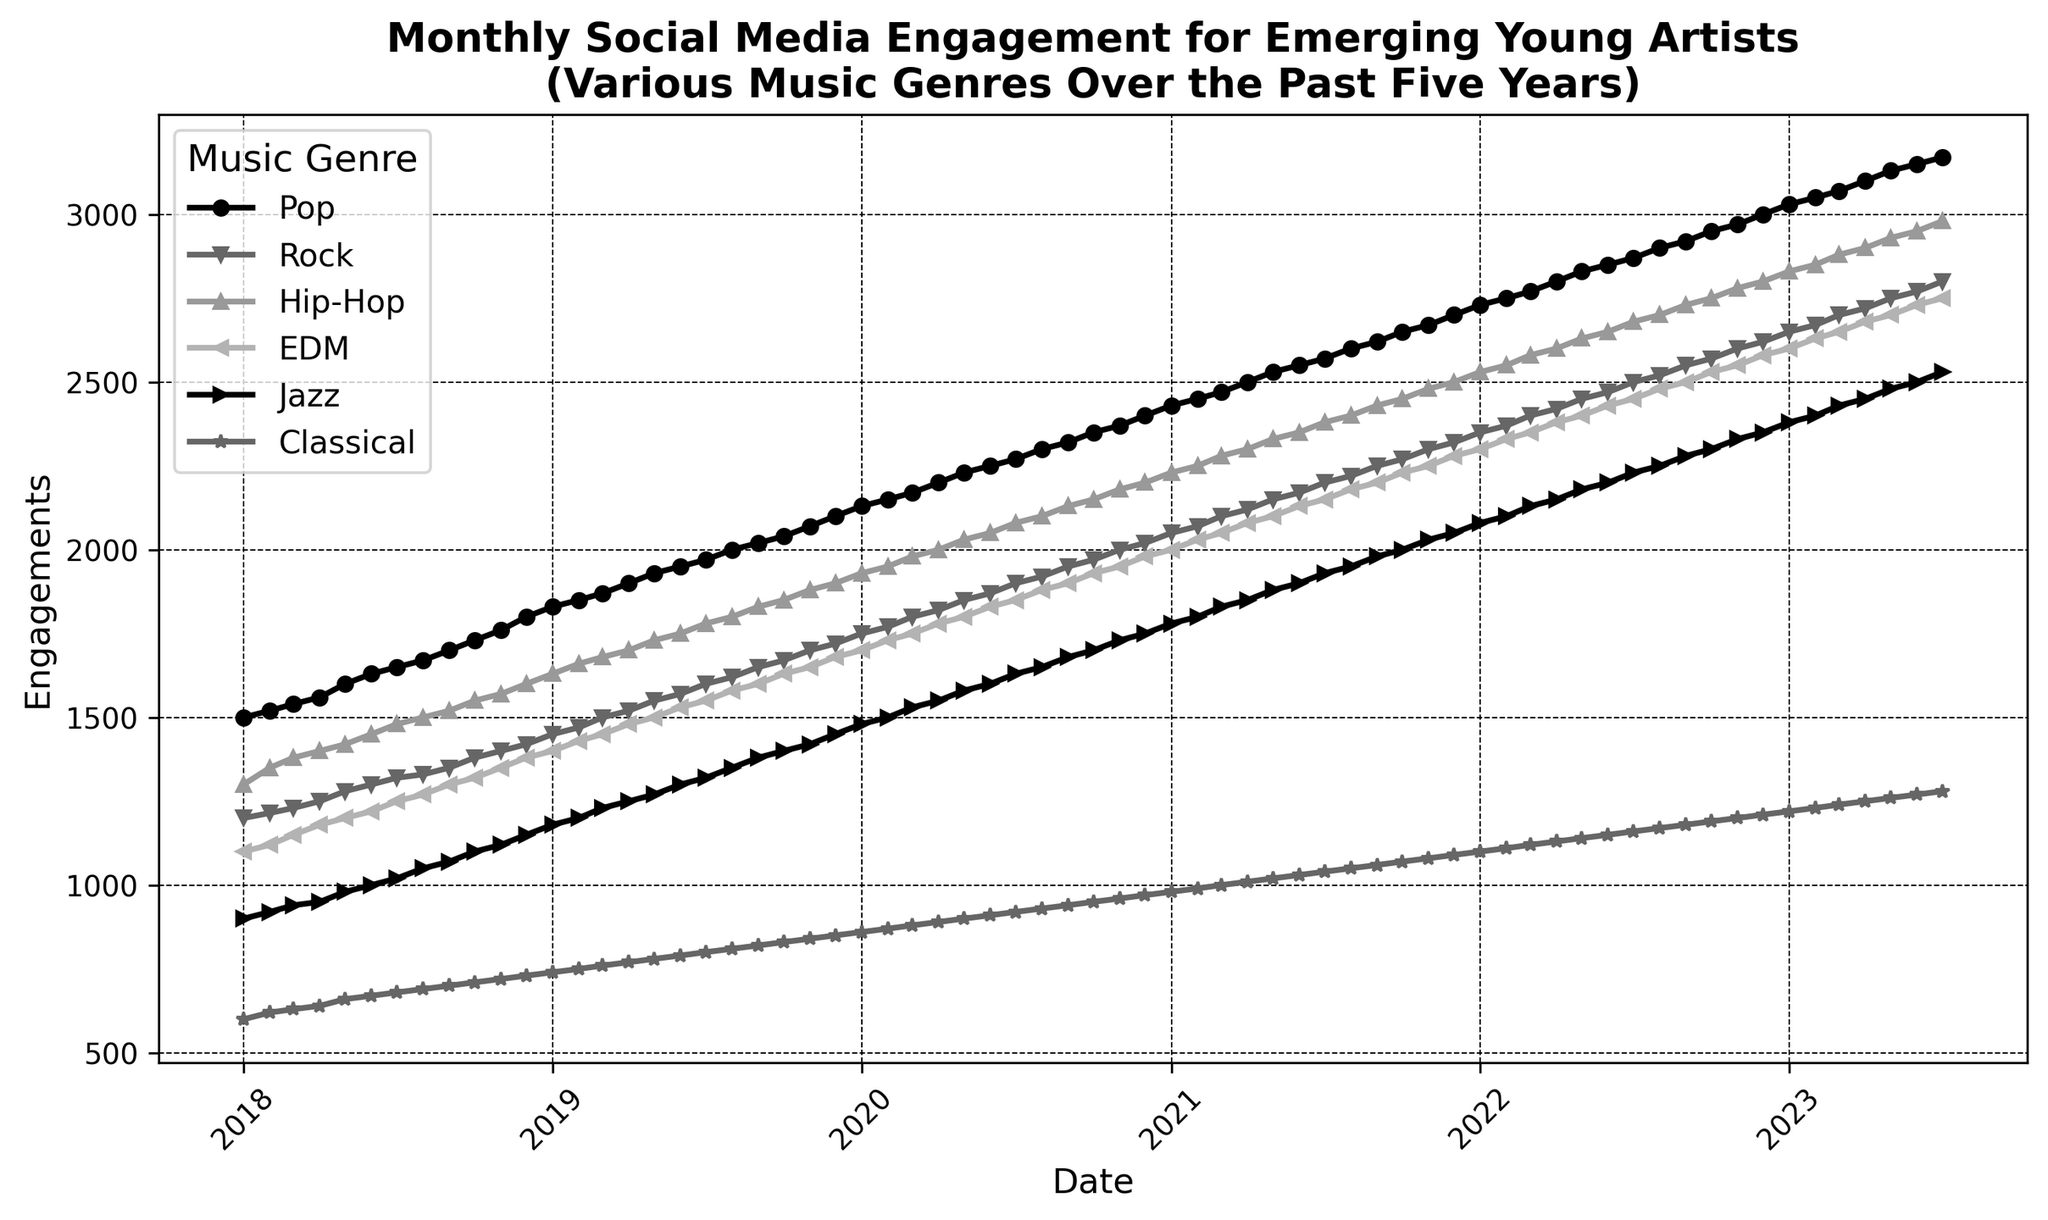Which genre shows the highest engagement in July 2023? From the plot, we look for the genre line that peaks in July 2023. The genres are indicated by different markers, and "Hip-Hop" reaches the highest point in that month.
Answer: Hip-Hop Did Rock engagement ever surpass Pop engagement from 2018 to 2023? We compare the lines representing Rock and Pop over the entire timeline. The Pop line is always above the Rock line, indicating Rock never surpassed Pop in engagement.
Answer: No Which month in 2019 did EDM see the fastest growth in engagement? By examining the EDM line, we observe the segments for sharpest increases. Between October and November 2019, there is the steepest incline in the plot for EDM.
Answer: November 2019 Between Jazz and Classical, which genre had a higher engagement by the end of 2021? We focus on the endpoint in December 2021 for both Jazz and Classical lines. Jazz ends higher than Classical according to the height of the lines.
Answer: Jazz On average, how many engagements did Classical music receive per year? To find the average per year, sum the engagements per year and then divide by the number of months. For instance, in 2018, Classical received 600+620+...+740 = 9240, average = 9240/12 = 770; repeat for all years and average this result.
Answer: 970.5 What's the total engagement growth for Hip-Hop from January 2018 to July 2023? Determine the engagement in January 2018 (1300) and in July 2023 (2980), then calculate the difference: 2980 - 1300.
Answer: 1680 Which genre consistently showed the least engagement over the entire period? By checking the relative height and position of the lines across the entire timeline, Classical consistently showed the lowest engagement.
Answer: Classical During which year did Pop's engagement increase the most? Look at the yearly increments for Pop. Calculate the difference for each year, with 2020 showing the largest increase from 2100 to 2400 (300 increment).
Answer: 2020 Compare the engagement of EDM and Jazz in March 2020. Which had higher and by how much? Locate the engagement values in March 2020 for EDM (1750) and Jazz (1530). Subtract Jazz's value from EDM's: 1750 - 1530.
Answer: EDM by 220 Which genre reached 2000 engagements first and in which month? Find the earliest point where each genre hits 2000 engagements. Pop is the first to reach it in September 2019.
Answer: Pop, September 2019 